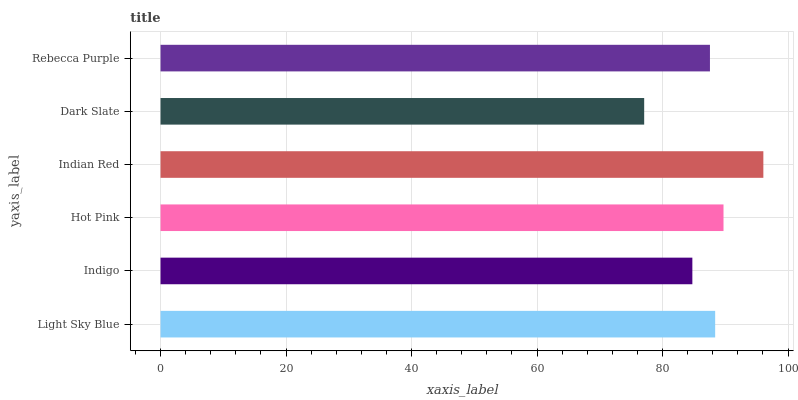Is Dark Slate the minimum?
Answer yes or no. Yes. Is Indian Red the maximum?
Answer yes or no. Yes. Is Indigo the minimum?
Answer yes or no. No. Is Indigo the maximum?
Answer yes or no. No. Is Light Sky Blue greater than Indigo?
Answer yes or no. Yes. Is Indigo less than Light Sky Blue?
Answer yes or no. Yes. Is Indigo greater than Light Sky Blue?
Answer yes or no. No. Is Light Sky Blue less than Indigo?
Answer yes or no. No. Is Light Sky Blue the high median?
Answer yes or no. Yes. Is Rebecca Purple the low median?
Answer yes or no. Yes. Is Hot Pink the high median?
Answer yes or no. No. Is Hot Pink the low median?
Answer yes or no. No. 